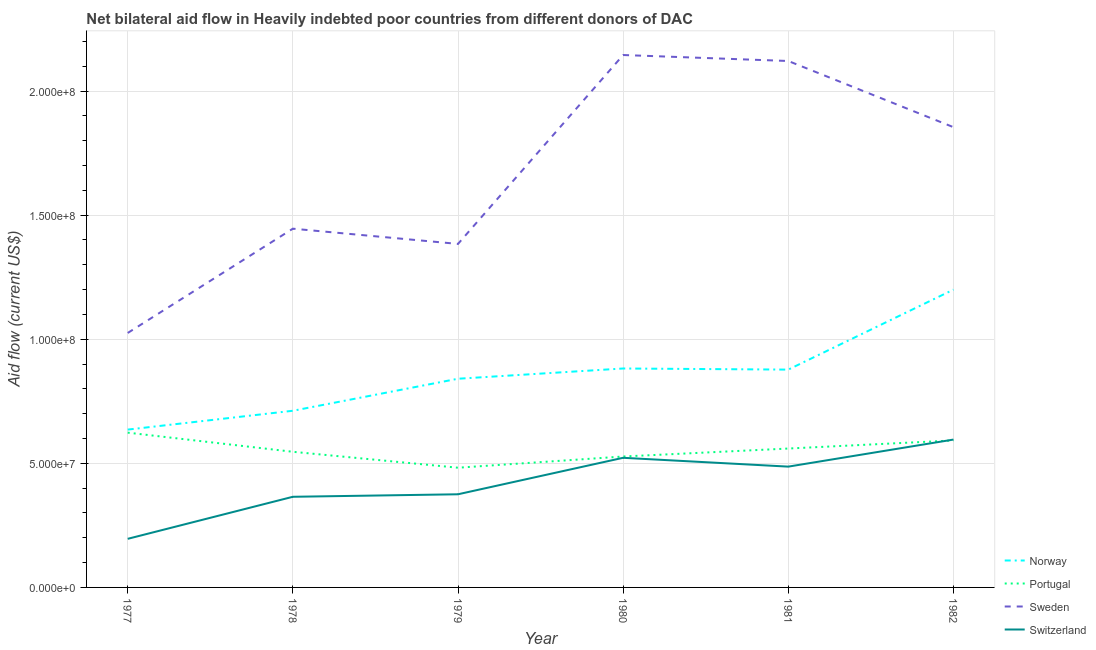Does the line corresponding to amount of aid given by portugal intersect with the line corresponding to amount of aid given by norway?
Offer a very short reply. No. Is the number of lines equal to the number of legend labels?
Your answer should be very brief. Yes. What is the amount of aid given by sweden in 1979?
Give a very brief answer. 1.38e+08. Across all years, what is the maximum amount of aid given by sweden?
Your response must be concise. 2.15e+08. Across all years, what is the minimum amount of aid given by sweden?
Ensure brevity in your answer.  1.03e+08. In which year was the amount of aid given by portugal maximum?
Offer a terse response. 1977. What is the total amount of aid given by norway in the graph?
Offer a terse response. 5.15e+08. What is the difference between the amount of aid given by switzerland in 1978 and that in 1981?
Your response must be concise. -1.22e+07. What is the difference between the amount of aid given by portugal in 1981 and the amount of aid given by switzerland in 1979?
Ensure brevity in your answer.  1.84e+07. What is the average amount of aid given by portugal per year?
Offer a very short reply. 5.55e+07. In the year 1978, what is the difference between the amount of aid given by sweden and amount of aid given by norway?
Make the answer very short. 7.34e+07. What is the ratio of the amount of aid given by sweden in 1977 to that in 1979?
Make the answer very short. 0.74. Is the amount of aid given by switzerland in 1977 less than that in 1979?
Provide a short and direct response. Yes. What is the difference between the highest and the second highest amount of aid given by portugal?
Make the answer very short. 3.14e+06. What is the difference between the highest and the lowest amount of aid given by sweden?
Keep it short and to the point. 1.12e+08. In how many years, is the amount of aid given by norway greater than the average amount of aid given by norway taken over all years?
Keep it short and to the point. 3. Does the amount of aid given by sweden monotonically increase over the years?
Provide a succinct answer. No. Is the amount of aid given by portugal strictly greater than the amount of aid given by sweden over the years?
Make the answer very short. No. How many lines are there?
Your answer should be compact. 4. What is the difference between two consecutive major ticks on the Y-axis?
Provide a short and direct response. 5.00e+07. Are the values on the major ticks of Y-axis written in scientific E-notation?
Ensure brevity in your answer.  Yes. Does the graph contain any zero values?
Offer a very short reply. No. What is the title of the graph?
Provide a short and direct response. Net bilateral aid flow in Heavily indebted poor countries from different donors of DAC. What is the label or title of the X-axis?
Offer a very short reply. Year. What is the label or title of the Y-axis?
Ensure brevity in your answer.  Aid flow (current US$). What is the Aid flow (current US$) in Norway in 1977?
Provide a succinct answer. 6.36e+07. What is the Aid flow (current US$) of Portugal in 1977?
Your response must be concise. 6.24e+07. What is the Aid flow (current US$) in Sweden in 1977?
Your answer should be very brief. 1.03e+08. What is the Aid flow (current US$) in Switzerland in 1977?
Offer a terse response. 1.96e+07. What is the Aid flow (current US$) of Norway in 1978?
Ensure brevity in your answer.  7.12e+07. What is the Aid flow (current US$) in Portugal in 1978?
Offer a terse response. 5.46e+07. What is the Aid flow (current US$) in Sweden in 1978?
Provide a succinct answer. 1.45e+08. What is the Aid flow (current US$) in Switzerland in 1978?
Provide a short and direct response. 3.65e+07. What is the Aid flow (current US$) of Norway in 1979?
Provide a short and direct response. 8.41e+07. What is the Aid flow (current US$) in Portugal in 1979?
Make the answer very short. 4.82e+07. What is the Aid flow (current US$) in Sweden in 1979?
Ensure brevity in your answer.  1.38e+08. What is the Aid flow (current US$) in Switzerland in 1979?
Ensure brevity in your answer.  3.75e+07. What is the Aid flow (current US$) in Norway in 1980?
Offer a terse response. 8.82e+07. What is the Aid flow (current US$) in Portugal in 1980?
Your response must be concise. 5.28e+07. What is the Aid flow (current US$) in Sweden in 1980?
Give a very brief answer. 2.15e+08. What is the Aid flow (current US$) in Switzerland in 1980?
Your answer should be compact. 5.22e+07. What is the Aid flow (current US$) in Norway in 1981?
Provide a succinct answer. 8.78e+07. What is the Aid flow (current US$) of Portugal in 1981?
Give a very brief answer. 5.60e+07. What is the Aid flow (current US$) in Sweden in 1981?
Give a very brief answer. 2.12e+08. What is the Aid flow (current US$) of Switzerland in 1981?
Offer a very short reply. 4.87e+07. What is the Aid flow (current US$) in Norway in 1982?
Your response must be concise. 1.20e+08. What is the Aid flow (current US$) of Portugal in 1982?
Offer a terse response. 5.92e+07. What is the Aid flow (current US$) of Sweden in 1982?
Give a very brief answer. 1.85e+08. What is the Aid flow (current US$) of Switzerland in 1982?
Give a very brief answer. 5.96e+07. Across all years, what is the maximum Aid flow (current US$) of Norway?
Give a very brief answer. 1.20e+08. Across all years, what is the maximum Aid flow (current US$) of Portugal?
Keep it short and to the point. 6.24e+07. Across all years, what is the maximum Aid flow (current US$) in Sweden?
Your response must be concise. 2.15e+08. Across all years, what is the maximum Aid flow (current US$) of Switzerland?
Make the answer very short. 5.96e+07. Across all years, what is the minimum Aid flow (current US$) of Norway?
Keep it short and to the point. 6.36e+07. Across all years, what is the minimum Aid flow (current US$) of Portugal?
Keep it short and to the point. 4.82e+07. Across all years, what is the minimum Aid flow (current US$) in Sweden?
Provide a succinct answer. 1.03e+08. Across all years, what is the minimum Aid flow (current US$) in Switzerland?
Your answer should be compact. 1.96e+07. What is the total Aid flow (current US$) of Norway in the graph?
Your response must be concise. 5.15e+08. What is the total Aid flow (current US$) in Portugal in the graph?
Ensure brevity in your answer.  3.33e+08. What is the total Aid flow (current US$) of Sweden in the graph?
Provide a short and direct response. 9.98e+08. What is the total Aid flow (current US$) in Switzerland in the graph?
Make the answer very short. 2.54e+08. What is the difference between the Aid flow (current US$) of Norway in 1977 and that in 1978?
Your response must be concise. -7.59e+06. What is the difference between the Aid flow (current US$) in Portugal in 1977 and that in 1978?
Make the answer very short. 7.71e+06. What is the difference between the Aid flow (current US$) in Sweden in 1977 and that in 1978?
Ensure brevity in your answer.  -4.20e+07. What is the difference between the Aid flow (current US$) of Switzerland in 1977 and that in 1978?
Provide a short and direct response. -1.69e+07. What is the difference between the Aid flow (current US$) of Norway in 1977 and that in 1979?
Offer a very short reply. -2.05e+07. What is the difference between the Aid flow (current US$) in Portugal in 1977 and that in 1979?
Provide a short and direct response. 1.41e+07. What is the difference between the Aid flow (current US$) in Sweden in 1977 and that in 1979?
Ensure brevity in your answer.  -3.59e+07. What is the difference between the Aid flow (current US$) in Switzerland in 1977 and that in 1979?
Keep it short and to the point. -1.80e+07. What is the difference between the Aid flow (current US$) in Norway in 1977 and that in 1980?
Provide a succinct answer. -2.46e+07. What is the difference between the Aid flow (current US$) in Portugal in 1977 and that in 1980?
Your answer should be compact. 9.61e+06. What is the difference between the Aid flow (current US$) of Sweden in 1977 and that in 1980?
Provide a short and direct response. -1.12e+08. What is the difference between the Aid flow (current US$) of Switzerland in 1977 and that in 1980?
Provide a short and direct response. -3.26e+07. What is the difference between the Aid flow (current US$) of Norway in 1977 and that in 1981?
Keep it short and to the point. -2.42e+07. What is the difference between the Aid flow (current US$) in Portugal in 1977 and that in 1981?
Your answer should be compact. 6.40e+06. What is the difference between the Aid flow (current US$) of Sweden in 1977 and that in 1981?
Your answer should be compact. -1.10e+08. What is the difference between the Aid flow (current US$) in Switzerland in 1977 and that in 1981?
Keep it short and to the point. -2.91e+07. What is the difference between the Aid flow (current US$) of Norway in 1977 and that in 1982?
Ensure brevity in your answer.  -5.64e+07. What is the difference between the Aid flow (current US$) of Portugal in 1977 and that in 1982?
Offer a terse response. 3.14e+06. What is the difference between the Aid flow (current US$) in Sweden in 1977 and that in 1982?
Provide a succinct answer. -8.29e+07. What is the difference between the Aid flow (current US$) in Switzerland in 1977 and that in 1982?
Provide a succinct answer. -4.00e+07. What is the difference between the Aid flow (current US$) of Norway in 1978 and that in 1979?
Provide a short and direct response. -1.29e+07. What is the difference between the Aid flow (current US$) of Portugal in 1978 and that in 1979?
Offer a very short reply. 6.42e+06. What is the difference between the Aid flow (current US$) in Sweden in 1978 and that in 1979?
Provide a short and direct response. 6.14e+06. What is the difference between the Aid flow (current US$) of Switzerland in 1978 and that in 1979?
Keep it short and to the point. -1.01e+06. What is the difference between the Aid flow (current US$) of Norway in 1978 and that in 1980?
Your response must be concise. -1.70e+07. What is the difference between the Aid flow (current US$) in Portugal in 1978 and that in 1980?
Your answer should be compact. 1.90e+06. What is the difference between the Aid flow (current US$) of Sweden in 1978 and that in 1980?
Provide a succinct answer. -7.00e+07. What is the difference between the Aid flow (current US$) of Switzerland in 1978 and that in 1980?
Make the answer very short. -1.57e+07. What is the difference between the Aid flow (current US$) of Norway in 1978 and that in 1981?
Your answer should be very brief. -1.66e+07. What is the difference between the Aid flow (current US$) in Portugal in 1978 and that in 1981?
Offer a terse response. -1.31e+06. What is the difference between the Aid flow (current US$) in Sweden in 1978 and that in 1981?
Offer a very short reply. -6.76e+07. What is the difference between the Aid flow (current US$) of Switzerland in 1978 and that in 1981?
Offer a very short reply. -1.22e+07. What is the difference between the Aid flow (current US$) of Norway in 1978 and that in 1982?
Make the answer very short. -4.88e+07. What is the difference between the Aid flow (current US$) of Portugal in 1978 and that in 1982?
Your answer should be compact. -4.57e+06. What is the difference between the Aid flow (current US$) in Sweden in 1978 and that in 1982?
Your answer should be very brief. -4.09e+07. What is the difference between the Aid flow (current US$) of Switzerland in 1978 and that in 1982?
Ensure brevity in your answer.  -2.30e+07. What is the difference between the Aid flow (current US$) in Norway in 1979 and that in 1980?
Keep it short and to the point. -4.13e+06. What is the difference between the Aid flow (current US$) of Portugal in 1979 and that in 1980?
Provide a succinct answer. -4.52e+06. What is the difference between the Aid flow (current US$) of Sweden in 1979 and that in 1980?
Your answer should be very brief. -7.61e+07. What is the difference between the Aid flow (current US$) of Switzerland in 1979 and that in 1980?
Keep it short and to the point. -1.47e+07. What is the difference between the Aid flow (current US$) in Norway in 1979 and that in 1981?
Your answer should be compact. -3.68e+06. What is the difference between the Aid flow (current US$) in Portugal in 1979 and that in 1981?
Make the answer very short. -7.73e+06. What is the difference between the Aid flow (current US$) in Sweden in 1979 and that in 1981?
Your answer should be very brief. -7.37e+07. What is the difference between the Aid flow (current US$) of Switzerland in 1979 and that in 1981?
Your answer should be very brief. -1.11e+07. What is the difference between the Aid flow (current US$) in Norway in 1979 and that in 1982?
Your response must be concise. -3.59e+07. What is the difference between the Aid flow (current US$) of Portugal in 1979 and that in 1982?
Keep it short and to the point. -1.10e+07. What is the difference between the Aid flow (current US$) of Sweden in 1979 and that in 1982?
Give a very brief answer. -4.70e+07. What is the difference between the Aid flow (current US$) of Switzerland in 1979 and that in 1982?
Make the answer very short. -2.20e+07. What is the difference between the Aid flow (current US$) in Norway in 1980 and that in 1981?
Provide a succinct answer. 4.50e+05. What is the difference between the Aid flow (current US$) in Portugal in 1980 and that in 1981?
Make the answer very short. -3.21e+06. What is the difference between the Aid flow (current US$) in Sweden in 1980 and that in 1981?
Offer a terse response. 2.41e+06. What is the difference between the Aid flow (current US$) in Switzerland in 1980 and that in 1981?
Ensure brevity in your answer.  3.56e+06. What is the difference between the Aid flow (current US$) of Norway in 1980 and that in 1982?
Make the answer very short. -3.18e+07. What is the difference between the Aid flow (current US$) in Portugal in 1980 and that in 1982?
Your answer should be very brief. -6.47e+06. What is the difference between the Aid flow (current US$) of Sweden in 1980 and that in 1982?
Your response must be concise. 2.91e+07. What is the difference between the Aid flow (current US$) in Switzerland in 1980 and that in 1982?
Ensure brevity in your answer.  -7.34e+06. What is the difference between the Aid flow (current US$) of Norway in 1981 and that in 1982?
Your answer should be compact. -3.22e+07. What is the difference between the Aid flow (current US$) in Portugal in 1981 and that in 1982?
Your answer should be compact. -3.26e+06. What is the difference between the Aid flow (current US$) in Sweden in 1981 and that in 1982?
Your answer should be compact. 2.67e+07. What is the difference between the Aid flow (current US$) in Switzerland in 1981 and that in 1982?
Offer a terse response. -1.09e+07. What is the difference between the Aid flow (current US$) of Norway in 1977 and the Aid flow (current US$) of Portugal in 1978?
Provide a succinct answer. 8.94e+06. What is the difference between the Aid flow (current US$) in Norway in 1977 and the Aid flow (current US$) in Sweden in 1978?
Your answer should be compact. -8.10e+07. What is the difference between the Aid flow (current US$) of Norway in 1977 and the Aid flow (current US$) of Switzerland in 1978?
Your answer should be very brief. 2.71e+07. What is the difference between the Aid flow (current US$) in Portugal in 1977 and the Aid flow (current US$) in Sweden in 1978?
Your answer should be very brief. -8.22e+07. What is the difference between the Aid flow (current US$) of Portugal in 1977 and the Aid flow (current US$) of Switzerland in 1978?
Give a very brief answer. 2.58e+07. What is the difference between the Aid flow (current US$) in Sweden in 1977 and the Aid flow (current US$) in Switzerland in 1978?
Ensure brevity in your answer.  6.60e+07. What is the difference between the Aid flow (current US$) of Norway in 1977 and the Aid flow (current US$) of Portugal in 1979?
Offer a terse response. 1.54e+07. What is the difference between the Aid flow (current US$) in Norway in 1977 and the Aid flow (current US$) in Sweden in 1979?
Your response must be concise. -7.48e+07. What is the difference between the Aid flow (current US$) in Norway in 1977 and the Aid flow (current US$) in Switzerland in 1979?
Provide a succinct answer. 2.61e+07. What is the difference between the Aid flow (current US$) of Portugal in 1977 and the Aid flow (current US$) of Sweden in 1979?
Ensure brevity in your answer.  -7.60e+07. What is the difference between the Aid flow (current US$) of Portugal in 1977 and the Aid flow (current US$) of Switzerland in 1979?
Your answer should be very brief. 2.48e+07. What is the difference between the Aid flow (current US$) in Sweden in 1977 and the Aid flow (current US$) in Switzerland in 1979?
Your response must be concise. 6.50e+07. What is the difference between the Aid flow (current US$) in Norway in 1977 and the Aid flow (current US$) in Portugal in 1980?
Provide a succinct answer. 1.08e+07. What is the difference between the Aid flow (current US$) in Norway in 1977 and the Aid flow (current US$) in Sweden in 1980?
Provide a short and direct response. -1.51e+08. What is the difference between the Aid flow (current US$) of Norway in 1977 and the Aid flow (current US$) of Switzerland in 1980?
Your response must be concise. 1.14e+07. What is the difference between the Aid flow (current US$) of Portugal in 1977 and the Aid flow (current US$) of Sweden in 1980?
Provide a short and direct response. -1.52e+08. What is the difference between the Aid flow (current US$) of Portugal in 1977 and the Aid flow (current US$) of Switzerland in 1980?
Make the answer very short. 1.01e+07. What is the difference between the Aid flow (current US$) in Sweden in 1977 and the Aid flow (current US$) in Switzerland in 1980?
Provide a short and direct response. 5.03e+07. What is the difference between the Aid flow (current US$) in Norway in 1977 and the Aid flow (current US$) in Portugal in 1981?
Provide a short and direct response. 7.63e+06. What is the difference between the Aid flow (current US$) in Norway in 1977 and the Aid flow (current US$) in Sweden in 1981?
Give a very brief answer. -1.49e+08. What is the difference between the Aid flow (current US$) in Norway in 1977 and the Aid flow (current US$) in Switzerland in 1981?
Provide a short and direct response. 1.49e+07. What is the difference between the Aid flow (current US$) in Portugal in 1977 and the Aid flow (current US$) in Sweden in 1981?
Offer a terse response. -1.50e+08. What is the difference between the Aid flow (current US$) of Portugal in 1977 and the Aid flow (current US$) of Switzerland in 1981?
Give a very brief answer. 1.37e+07. What is the difference between the Aid flow (current US$) in Sweden in 1977 and the Aid flow (current US$) in Switzerland in 1981?
Your answer should be compact. 5.38e+07. What is the difference between the Aid flow (current US$) in Norway in 1977 and the Aid flow (current US$) in Portugal in 1982?
Keep it short and to the point. 4.37e+06. What is the difference between the Aid flow (current US$) in Norway in 1977 and the Aid flow (current US$) in Sweden in 1982?
Ensure brevity in your answer.  -1.22e+08. What is the difference between the Aid flow (current US$) of Norway in 1977 and the Aid flow (current US$) of Switzerland in 1982?
Give a very brief answer. 4.02e+06. What is the difference between the Aid flow (current US$) in Portugal in 1977 and the Aid flow (current US$) in Sweden in 1982?
Your answer should be very brief. -1.23e+08. What is the difference between the Aid flow (current US$) of Portugal in 1977 and the Aid flow (current US$) of Switzerland in 1982?
Ensure brevity in your answer.  2.79e+06. What is the difference between the Aid flow (current US$) of Sweden in 1977 and the Aid flow (current US$) of Switzerland in 1982?
Your response must be concise. 4.30e+07. What is the difference between the Aid flow (current US$) of Norway in 1978 and the Aid flow (current US$) of Portugal in 1979?
Your answer should be compact. 2.30e+07. What is the difference between the Aid flow (current US$) in Norway in 1978 and the Aid flow (current US$) in Sweden in 1979?
Offer a terse response. -6.72e+07. What is the difference between the Aid flow (current US$) in Norway in 1978 and the Aid flow (current US$) in Switzerland in 1979?
Your response must be concise. 3.36e+07. What is the difference between the Aid flow (current US$) of Portugal in 1978 and the Aid flow (current US$) of Sweden in 1979?
Your response must be concise. -8.38e+07. What is the difference between the Aid flow (current US$) of Portugal in 1978 and the Aid flow (current US$) of Switzerland in 1979?
Your response must be concise. 1.71e+07. What is the difference between the Aid flow (current US$) of Sweden in 1978 and the Aid flow (current US$) of Switzerland in 1979?
Offer a very short reply. 1.07e+08. What is the difference between the Aid flow (current US$) of Norway in 1978 and the Aid flow (current US$) of Portugal in 1980?
Your response must be concise. 1.84e+07. What is the difference between the Aid flow (current US$) in Norway in 1978 and the Aid flow (current US$) in Sweden in 1980?
Provide a succinct answer. -1.43e+08. What is the difference between the Aid flow (current US$) of Norway in 1978 and the Aid flow (current US$) of Switzerland in 1980?
Provide a short and direct response. 1.90e+07. What is the difference between the Aid flow (current US$) of Portugal in 1978 and the Aid flow (current US$) of Sweden in 1980?
Your response must be concise. -1.60e+08. What is the difference between the Aid flow (current US$) in Portugal in 1978 and the Aid flow (current US$) in Switzerland in 1980?
Your answer should be very brief. 2.42e+06. What is the difference between the Aid flow (current US$) of Sweden in 1978 and the Aid flow (current US$) of Switzerland in 1980?
Offer a terse response. 9.23e+07. What is the difference between the Aid flow (current US$) in Norway in 1978 and the Aid flow (current US$) in Portugal in 1981?
Provide a short and direct response. 1.52e+07. What is the difference between the Aid flow (current US$) of Norway in 1978 and the Aid flow (current US$) of Sweden in 1981?
Keep it short and to the point. -1.41e+08. What is the difference between the Aid flow (current US$) of Norway in 1978 and the Aid flow (current US$) of Switzerland in 1981?
Provide a short and direct response. 2.25e+07. What is the difference between the Aid flow (current US$) of Portugal in 1978 and the Aid flow (current US$) of Sweden in 1981?
Provide a succinct answer. -1.57e+08. What is the difference between the Aid flow (current US$) of Portugal in 1978 and the Aid flow (current US$) of Switzerland in 1981?
Provide a short and direct response. 5.98e+06. What is the difference between the Aid flow (current US$) in Sweden in 1978 and the Aid flow (current US$) in Switzerland in 1981?
Provide a short and direct response. 9.59e+07. What is the difference between the Aid flow (current US$) of Norway in 1978 and the Aid flow (current US$) of Portugal in 1982?
Give a very brief answer. 1.20e+07. What is the difference between the Aid flow (current US$) of Norway in 1978 and the Aid flow (current US$) of Sweden in 1982?
Give a very brief answer. -1.14e+08. What is the difference between the Aid flow (current US$) of Norway in 1978 and the Aid flow (current US$) of Switzerland in 1982?
Provide a succinct answer. 1.16e+07. What is the difference between the Aid flow (current US$) of Portugal in 1978 and the Aid flow (current US$) of Sweden in 1982?
Your response must be concise. -1.31e+08. What is the difference between the Aid flow (current US$) of Portugal in 1978 and the Aid flow (current US$) of Switzerland in 1982?
Provide a succinct answer. -4.92e+06. What is the difference between the Aid flow (current US$) in Sweden in 1978 and the Aid flow (current US$) in Switzerland in 1982?
Provide a short and direct response. 8.50e+07. What is the difference between the Aid flow (current US$) in Norway in 1979 and the Aid flow (current US$) in Portugal in 1980?
Provide a short and direct response. 3.13e+07. What is the difference between the Aid flow (current US$) in Norway in 1979 and the Aid flow (current US$) in Sweden in 1980?
Make the answer very short. -1.30e+08. What is the difference between the Aid flow (current US$) in Norway in 1979 and the Aid flow (current US$) in Switzerland in 1980?
Your answer should be compact. 3.18e+07. What is the difference between the Aid flow (current US$) of Portugal in 1979 and the Aid flow (current US$) of Sweden in 1980?
Your answer should be compact. -1.66e+08. What is the difference between the Aid flow (current US$) in Portugal in 1979 and the Aid flow (current US$) in Switzerland in 1980?
Give a very brief answer. -4.00e+06. What is the difference between the Aid flow (current US$) in Sweden in 1979 and the Aid flow (current US$) in Switzerland in 1980?
Ensure brevity in your answer.  8.62e+07. What is the difference between the Aid flow (current US$) of Norway in 1979 and the Aid flow (current US$) of Portugal in 1981?
Give a very brief answer. 2.81e+07. What is the difference between the Aid flow (current US$) of Norway in 1979 and the Aid flow (current US$) of Sweden in 1981?
Offer a terse response. -1.28e+08. What is the difference between the Aid flow (current US$) in Norway in 1979 and the Aid flow (current US$) in Switzerland in 1981?
Give a very brief answer. 3.54e+07. What is the difference between the Aid flow (current US$) of Portugal in 1979 and the Aid flow (current US$) of Sweden in 1981?
Provide a short and direct response. -1.64e+08. What is the difference between the Aid flow (current US$) in Portugal in 1979 and the Aid flow (current US$) in Switzerland in 1981?
Ensure brevity in your answer.  -4.40e+05. What is the difference between the Aid flow (current US$) of Sweden in 1979 and the Aid flow (current US$) of Switzerland in 1981?
Keep it short and to the point. 8.97e+07. What is the difference between the Aid flow (current US$) in Norway in 1979 and the Aid flow (current US$) in Portugal in 1982?
Offer a very short reply. 2.49e+07. What is the difference between the Aid flow (current US$) of Norway in 1979 and the Aid flow (current US$) of Sweden in 1982?
Your response must be concise. -1.01e+08. What is the difference between the Aid flow (current US$) in Norway in 1979 and the Aid flow (current US$) in Switzerland in 1982?
Keep it short and to the point. 2.45e+07. What is the difference between the Aid flow (current US$) of Portugal in 1979 and the Aid flow (current US$) of Sweden in 1982?
Your answer should be very brief. -1.37e+08. What is the difference between the Aid flow (current US$) in Portugal in 1979 and the Aid flow (current US$) in Switzerland in 1982?
Give a very brief answer. -1.13e+07. What is the difference between the Aid flow (current US$) of Sweden in 1979 and the Aid flow (current US$) of Switzerland in 1982?
Your answer should be compact. 7.88e+07. What is the difference between the Aid flow (current US$) of Norway in 1980 and the Aid flow (current US$) of Portugal in 1981?
Offer a terse response. 3.22e+07. What is the difference between the Aid flow (current US$) in Norway in 1980 and the Aid flow (current US$) in Sweden in 1981?
Keep it short and to the point. -1.24e+08. What is the difference between the Aid flow (current US$) in Norway in 1980 and the Aid flow (current US$) in Switzerland in 1981?
Keep it short and to the point. 3.95e+07. What is the difference between the Aid flow (current US$) in Portugal in 1980 and the Aid flow (current US$) in Sweden in 1981?
Give a very brief answer. -1.59e+08. What is the difference between the Aid flow (current US$) of Portugal in 1980 and the Aid flow (current US$) of Switzerland in 1981?
Provide a succinct answer. 4.08e+06. What is the difference between the Aid flow (current US$) in Sweden in 1980 and the Aid flow (current US$) in Switzerland in 1981?
Ensure brevity in your answer.  1.66e+08. What is the difference between the Aid flow (current US$) in Norway in 1980 and the Aid flow (current US$) in Portugal in 1982?
Provide a succinct answer. 2.90e+07. What is the difference between the Aid flow (current US$) of Norway in 1980 and the Aid flow (current US$) of Sweden in 1982?
Offer a very short reply. -9.72e+07. What is the difference between the Aid flow (current US$) in Norway in 1980 and the Aid flow (current US$) in Switzerland in 1982?
Your response must be concise. 2.86e+07. What is the difference between the Aid flow (current US$) in Portugal in 1980 and the Aid flow (current US$) in Sweden in 1982?
Provide a short and direct response. -1.33e+08. What is the difference between the Aid flow (current US$) in Portugal in 1980 and the Aid flow (current US$) in Switzerland in 1982?
Provide a succinct answer. -6.82e+06. What is the difference between the Aid flow (current US$) in Sweden in 1980 and the Aid flow (current US$) in Switzerland in 1982?
Provide a short and direct response. 1.55e+08. What is the difference between the Aid flow (current US$) of Norway in 1981 and the Aid flow (current US$) of Portugal in 1982?
Give a very brief answer. 2.85e+07. What is the difference between the Aid flow (current US$) in Norway in 1981 and the Aid flow (current US$) in Sweden in 1982?
Provide a succinct answer. -9.77e+07. What is the difference between the Aid flow (current US$) in Norway in 1981 and the Aid flow (current US$) in Switzerland in 1982?
Your answer should be compact. 2.82e+07. What is the difference between the Aid flow (current US$) of Portugal in 1981 and the Aid flow (current US$) of Sweden in 1982?
Your response must be concise. -1.29e+08. What is the difference between the Aid flow (current US$) in Portugal in 1981 and the Aid flow (current US$) in Switzerland in 1982?
Your answer should be very brief. -3.61e+06. What is the difference between the Aid flow (current US$) of Sweden in 1981 and the Aid flow (current US$) of Switzerland in 1982?
Ensure brevity in your answer.  1.53e+08. What is the average Aid flow (current US$) of Norway per year?
Provide a short and direct response. 8.58e+07. What is the average Aid flow (current US$) of Portugal per year?
Offer a terse response. 5.55e+07. What is the average Aid flow (current US$) of Sweden per year?
Provide a succinct answer. 1.66e+08. What is the average Aid flow (current US$) in Switzerland per year?
Offer a very short reply. 4.24e+07. In the year 1977, what is the difference between the Aid flow (current US$) of Norway and Aid flow (current US$) of Portugal?
Provide a succinct answer. 1.23e+06. In the year 1977, what is the difference between the Aid flow (current US$) in Norway and Aid flow (current US$) in Sweden?
Make the answer very short. -3.89e+07. In the year 1977, what is the difference between the Aid flow (current US$) in Norway and Aid flow (current US$) in Switzerland?
Your response must be concise. 4.40e+07. In the year 1977, what is the difference between the Aid flow (current US$) of Portugal and Aid flow (current US$) of Sweden?
Your response must be concise. -4.02e+07. In the year 1977, what is the difference between the Aid flow (current US$) in Portugal and Aid flow (current US$) in Switzerland?
Your answer should be very brief. 4.28e+07. In the year 1977, what is the difference between the Aid flow (current US$) of Sweden and Aid flow (current US$) of Switzerland?
Ensure brevity in your answer.  8.29e+07. In the year 1978, what is the difference between the Aid flow (current US$) of Norway and Aid flow (current US$) of Portugal?
Offer a very short reply. 1.65e+07. In the year 1978, what is the difference between the Aid flow (current US$) in Norway and Aid flow (current US$) in Sweden?
Offer a very short reply. -7.34e+07. In the year 1978, what is the difference between the Aid flow (current US$) in Norway and Aid flow (current US$) in Switzerland?
Keep it short and to the point. 3.47e+07. In the year 1978, what is the difference between the Aid flow (current US$) in Portugal and Aid flow (current US$) in Sweden?
Ensure brevity in your answer.  -8.99e+07. In the year 1978, what is the difference between the Aid flow (current US$) in Portugal and Aid flow (current US$) in Switzerland?
Your answer should be very brief. 1.81e+07. In the year 1978, what is the difference between the Aid flow (current US$) of Sweden and Aid flow (current US$) of Switzerland?
Your answer should be compact. 1.08e+08. In the year 1979, what is the difference between the Aid flow (current US$) in Norway and Aid flow (current US$) in Portugal?
Offer a very short reply. 3.58e+07. In the year 1979, what is the difference between the Aid flow (current US$) of Norway and Aid flow (current US$) of Sweden?
Your response must be concise. -5.43e+07. In the year 1979, what is the difference between the Aid flow (current US$) in Norway and Aid flow (current US$) in Switzerland?
Provide a short and direct response. 4.66e+07. In the year 1979, what is the difference between the Aid flow (current US$) in Portugal and Aid flow (current US$) in Sweden?
Offer a terse response. -9.02e+07. In the year 1979, what is the difference between the Aid flow (current US$) of Portugal and Aid flow (current US$) of Switzerland?
Give a very brief answer. 1.07e+07. In the year 1979, what is the difference between the Aid flow (current US$) of Sweden and Aid flow (current US$) of Switzerland?
Ensure brevity in your answer.  1.01e+08. In the year 1980, what is the difference between the Aid flow (current US$) in Norway and Aid flow (current US$) in Portugal?
Your answer should be compact. 3.55e+07. In the year 1980, what is the difference between the Aid flow (current US$) of Norway and Aid flow (current US$) of Sweden?
Your answer should be very brief. -1.26e+08. In the year 1980, what is the difference between the Aid flow (current US$) of Norway and Aid flow (current US$) of Switzerland?
Provide a short and direct response. 3.60e+07. In the year 1980, what is the difference between the Aid flow (current US$) in Portugal and Aid flow (current US$) in Sweden?
Provide a succinct answer. -1.62e+08. In the year 1980, what is the difference between the Aid flow (current US$) of Portugal and Aid flow (current US$) of Switzerland?
Make the answer very short. 5.20e+05. In the year 1980, what is the difference between the Aid flow (current US$) in Sweden and Aid flow (current US$) in Switzerland?
Your response must be concise. 1.62e+08. In the year 1981, what is the difference between the Aid flow (current US$) of Norway and Aid flow (current US$) of Portugal?
Your response must be concise. 3.18e+07. In the year 1981, what is the difference between the Aid flow (current US$) of Norway and Aid flow (current US$) of Sweden?
Offer a very short reply. -1.24e+08. In the year 1981, what is the difference between the Aid flow (current US$) of Norway and Aid flow (current US$) of Switzerland?
Your answer should be compact. 3.91e+07. In the year 1981, what is the difference between the Aid flow (current US$) of Portugal and Aid flow (current US$) of Sweden?
Your response must be concise. -1.56e+08. In the year 1981, what is the difference between the Aid flow (current US$) of Portugal and Aid flow (current US$) of Switzerland?
Offer a terse response. 7.29e+06. In the year 1981, what is the difference between the Aid flow (current US$) of Sweden and Aid flow (current US$) of Switzerland?
Your answer should be very brief. 1.63e+08. In the year 1982, what is the difference between the Aid flow (current US$) in Norway and Aid flow (current US$) in Portugal?
Your response must be concise. 6.08e+07. In the year 1982, what is the difference between the Aid flow (current US$) of Norway and Aid flow (current US$) of Sweden?
Provide a succinct answer. -6.55e+07. In the year 1982, what is the difference between the Aid flow (current US$) of Norway and Aid flow (current US$) of Switzerland?
Your response must be concise. 6.04e+07. In the year 1982, what is the difference between the Aid flow (current US$) in Portugal and Aid flow (current US$) in Sweden?
Keep it short and to the point. -1.26e+08. In the year 1982, what is the difference between the Aid flow (current US$) in Portugal and Aid flow (current US$) in Switzerland?
Your answer should be very brief. -3.50e+05. In the year 1982, what is the difference between the Aid flow (current US$) in Sweden and Aid flow (current US$) in Switzerland?
Keep it short and to the point. 1.26e+08. What is the ratio of the Aid flow (current US$) of Norway in 1977 to that in 1978?
Make the answer very short. 0.89. What is the ratio of the Aid flow (current US$) in Portugal in 1977 to that in 1978?
Your response must be concise. 1.14. What is the ratio of the Aid flow (current US$) of Sweden in 1977 to that in 1978?
Provide a succinct answer. 0.71. What is the ratio of the Aid flow (current US$) of Switzerland in 1977 to that in 1978?
Provide a short and direct response. 0.54. What is the ratio of the Aid flow (current US$) in Norway in 1977 to that in 1979?
Offer a very short reply. 0.76. What is the ratio of the Aid flow (current US$) in Portugal in 1977 to that in 1979?
Your response must be concise. 1.29. What is the ratio of the Aid flow (current US$) of Sweden in 1977 to that in 1979?
Provide a succinct answer. 0.74. What is the ratio of the Aid flow (current US$) of Switzerland in 1977 to that in 1979?
Provide a succinct answer. 0.52. What is the ratio of the Aid flow (current US$) of Norway in 1977 to that in 1980?
Make the answer very short. 0.72. What is the ratio of the Aid flow (current US$) of Portugal in 1977 to that in 1980?
Give a very brief answer. 1.18. What is the ratio of the Aid flow (current US$) of Sweden in 1977 to that in 1980?
Ensure brevity in your answer.  0.48. What is the ratio of the Aid flow (current US$) of Switzerland in 1977 to that in 1980?
Offer a terse response. 0.37. What is the ratio of the Aid flow (current US$) of Norway in 1977 to that in 1981?
Provide a short and direct response. 0.72. What is the ratio of the Aid flow (current US$) of Portugal in 1977 to that in 1981?
Provide a succinct answer. 1.11. What is the ratio of the Aid flow (current US$) of Sweden in 1977 to that in 1981?
Offer a very short reply. 0.48. What is the ratio of the Aid flow (current US$) of Switzerland in 1977 to that in 1981?
Offer a very short reply. 0.4. What is the ratio of the Aid flow (current US$) of Norway in 1977 to that in 1982?
Your response must be concise. 0.53. What is the ratio of the Aid flow (current US$) in Portugal in 1977 to that in 1982?
Provide a succinct answer. 1.05. What is the ratio of the Aid flow (current US$) of Sweden in 1977 to that in 1982?
Give a very brief answer. 0.55. What is the ratio of the Aid flow (current US$) of Switzerland in 1977 to that in 1982?
Give a very brief answer. 0.33. What is the ratio of the Aid flow (current US$) in Norway in 1978 to that in 1979?
Provide a short and direct response. 0.85. What is the ratio of the Aid flow (current US$) in Portugal in 1978 to that in 1979?
Make the answer very short. 1.13. What is the ratio of the Aid flow (current US$) of Sweden in 1978 to that in 1979?
Offer a terse response. 1.04. What is the ratio of the Aid flow (current US$) in Switzerland in 1978 to that in 1979?
Give a very brief answer. 0.97. What is the ratio of the Aid flow (current US$) in Norway in 1978 to that in 1980?
Offer a terse response. 0.81. What is the ratio of the Aid flow (current US$) of Portugal in 1978 to that in 1980?
Your answer should be very brief. 1.04. What is the ratio of the Aid flow (current US$) of Sweden in 1978 to that in 1980?
Offer a terse response. 0.67. What is the ratio of the Aid flow (current US$) of Switzerland in 1978 to that in 1980?
Your answer should be compact. 0.7. What is the ratio of the Aid flow (current US$) in Norway in 1978 to that in 1981?
Keep it short and to the point. 0.81. What is the ratio of the Aid flow (current US$) in Portugal in 1978 to that in 1981?
Your answer should be very brief. 0.98. What is the ratio of the Aid flow (current US$) of Sweden in 1978 to that in 1981?
Ensure brevity in your answer.  0.68. What is the ratio of the Aid flow (current US$) of Switzerland in 1978 to that in 1981?
Ensure brevity in your answer.  0.75. What is the ratio of the Aid flow (current US$) in Norway in 1978 to that in 1982?
Ensure brevity in your answer.  0.59. What is the ratio of the Aid flow (current US$) in Portugal in 1978 to that in 1982?
Your answer should be very brief. 0.92. What is the ratio of the Aid flow (current US$) of Sweden in 1978 to that in 1982?
Your answer should be very brief. 0.78. What is the ratio of the Aid flow (current US$) of Switzerland in 1978 to that in 1982?
Give a very brief answer. 0.61. What is the ratio of the Aid flow (current US$) in Norway in 1979 to that in 1980?
Your answer should be compact. 0.95. What is the ratio of the Aid flow (current US$) in Portugal in 1979 to that in 1980?
Offer a terse response. 0.91. What is the ratio of the Aid flow (current US$) in Sweden in 1979 to that in 1980?
Make the answer very short. 0.65. What is the ratio of the Aid flow (current US$) in Switzerland in 1979 to that in 1980?
Your response must be concise. 0.72. What is the ratio of the Aid flow (current US$) in Norway in 1979 to that in 1981?
Give a very brief answer. 0.96. What is the ratio of the Aid flow (current US$) in Portugal in 1979 to that in 1981?
Give a very brief answer. 0.86. What is the ratio of the Aid flow (current US$) of Sweden in 1979 to that in 1981?
Your response must be concise. 0.65. What is the ratio of the Aid flow (current US$) of Switzerland in 1979 to that in 1981?
Offer a terse response. 0.77. What is the ratio of the Aid flow (current US$) in Norway in 1979 to that in 1982?
Provide a succinct answer. 0.7. What is the ratio of the Aid flow (current US$) in Portugal in 1979 to that in 1982?
Your answer should be very brief. 0.81. What is the ratio of the Aid flow (current US$) in Sweden in 1979 to that in 1982?
Offer a terse response. 0.75. What is the ratio of the Aid flow (current US$) of Switzerland in 1979 to that in 1982?
Your answer should be very brief. 0.63. What is the ratio of the Aid flow (current US$) in Norway in 1980 to that in 1981?
Provide a short and direct response. 1.01. What is the ratio of the Aid flow (current US$) of Portugal in 1980 to that in 1981?
Offer a terse response. 0.94. What is the ratio of the Aid flow (current US$) in Sweden in 1980 to that in 1981?
Provide a succinct answer. 1.01. What is the ratio of the Aid flow (current US$) in Switzerland in 1980 to that in 1981?
Your answer should be very brief. 1.07. What is the ratio of the Aid flow (current US$) of Norway in 1980 to that in 1982?
Ensure brevity in your answer.  0.74. What is the ratio of the Aid flow (current US$) in Portugal in 1980 to that in 1982?
Keep it short and to the point. 0.89. What is the ratio of the Aid flow (current US$) of Sweden in 1980 to that in 1982?
Provide a short and direct response. 1.16. What is the ratio of the Aid flow (current US$) of Switzerland in 1980 to that in 1982?
Provide a short and direct response. 0.88. What is the ratio of the Aid flow (current US$) of Norway in 1981 to that in 1982?
Your answer should be very brief. 0.73. What is the ratio of the Aid flow (current US$) in Portugal in 1981 to that in 1982?
Provide a short and direct response. 0.94. What is the ratio of the Aid flow (current US$) of Sweden in 1981 to that in 1982?
Your response must be concise. 1.14. What is the ratio of the Aid flow (current US$) of Switzerland in 1981 to that in 1982?
Offer a very short reply. 0.82. What is the difference between the highest and the second highest Aid flow (current US$) in Norway?
Provide a short and direct response. 3.18e+07. What is the difference between the highest and the second highest Aid flow (current US$) of Portugal?
Keep it short and to the point. 3.14e+06. What is the difference between the highest and the second highest Aid flow (current US$) in Sweden?
Your response must be concise. 2.41e+06. What is the difference between the highest and the second highest Aid flow (current US$) of Switzerland?
Offer a terse response. 7.34e+06. What is the difference between the highest and the lowest Aid flow (current US$) in Norway?
Ensure brevity in your answer.  5.64e+07. What is the difference between the highest and the lowest Aid flow (current US$) of Portugal?
Your answer should be very brief. 1.41e+07. What is the difference between the highest and the lowest Aid flow (current US$) in Sweden?
Offer a very short reply. 1.12e+08. What is the difference between the highest and the lowest Aid flow (current US$) in Switzerland?
Offer a very short reply. 4.00e+07. 